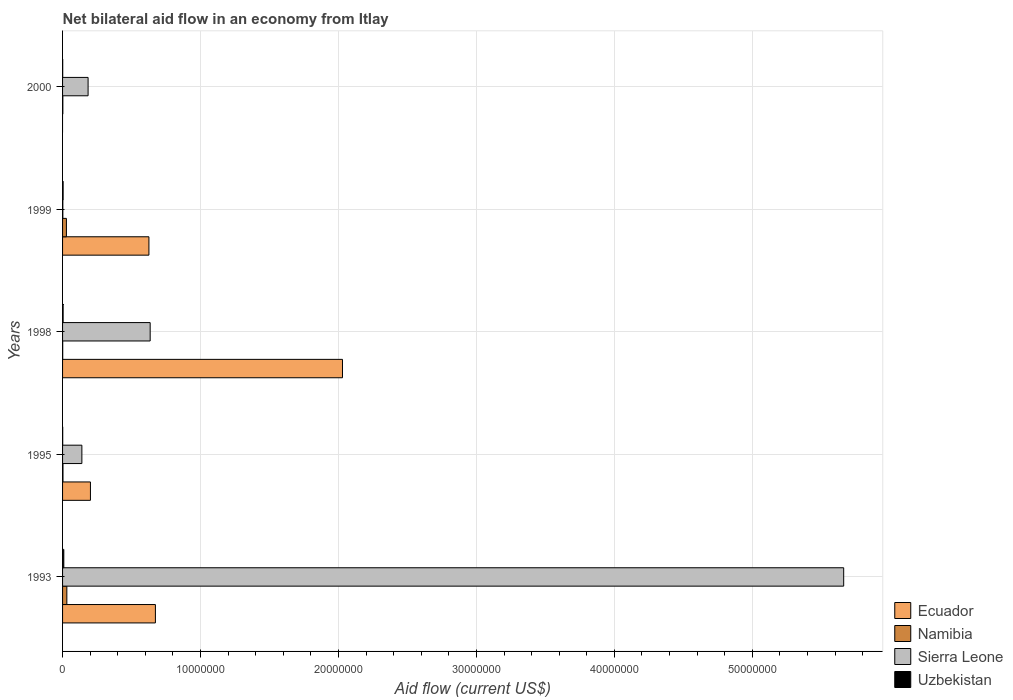How many different coloured bars are there?
Offer a terse response. 4. Are the number of bars per tick equal to the number of legend labels?
Your response must be concise. No. Are the number of bars on each tick of the Y-axis equal?
Provide a short and direct response. No. How many bars are there on the 3rd tick from the bottom?
Keep it short and to the point. 4. What is the label of the 5th group of bars from the top?
Provide a succinct answer. 1993. In how many cases, is the number of bars for a given year not equal to the number of legend labels?
Offer a very short reply. 1. What is the net bilateral aid flow in Uzbekistan in 1993?
Make the answer very short. 9.00e+04. Across all years, what is the maximum net bilateral aid flow in Ecuador?
Ensure brevity in your answer.  2.03e+07. Across all years, what is the minimum net bilateral aid flow in Ecuador?
Keep it short and to the point. 0. In which year was the net bilateral aid flow in Sierra Leone maximum?
Your answer should be compact. 1993. What is the difference between the net bilateral aid flow in Sierra Leone in 1993 and that in 2000?
Make the answer very short. 5.48e+07. What is the difference between the net bilateral aid flow in Namibia in 1993 and the net bilateral aid flow in Sierra Leone in 1995?
Ensure brevity in your answer.  -1.09e+06. In the year 2000, what is the difference between the net bilateral aid flow in Uzbekistan and net bilateral aid flow in Sierra Leone?
Provide a short and direct response. -1.84e+06. What is the ratio of the net bilateral aid flow in Uzbekistan in 1998 to that in 2000?
Your answer should be compact. 4. What is the difference between the highest and the second highest net bilateral aid flow in Sierra Leone?
Your answer should be very brief. 5.03e+07. What is the difference between the highest and the lowest net bilateral aid flow in Sierra Leone?
Offer a very short reply. 5.66e+07. Is the sum of the net bilateral aid flow in Ecuador in 1998 and 1999 greater than the maximum net bilateral aid flow in Uzbekistan across all years?
Provide a succinct answer. Yes. Is it the case that in every year, the sum of the net bilateral aid flow in Uzbekistan and net bilateral aid flow in Sierra Leone is greater than the sum of net bilateral aid flow in Ecuador and net bilateral aid flow in Namibia?
Your answer should be compact. No. Are the values on the major ticks of X-axis written in scientific E-notation?
Your answer should be compact. No. Does the graph contain any zero values?
Your response must be concise. Yes. Does the graph contain grids?
Provide a succinct answer. Yes. Where does the legend appear in the graph?
Make the answer very short. Bottom right. How many legend labels are there?
Give a very brief answer. 4. How are the legend labels stacked?
Keep it short and to the point. Vertical. What is the title of the graph?
Give a very brief answer. Net bilateral aid flow in an economy from Itlay. Does "Belize" appear as one of the legend labels in the graph?
Make the answer very short. No. What is the label or title of the X-axis?
Provide a succinct answer. Aid flow (current US$). What is the Aid flow (current US$) in Ecuador in 1993?
Offer a very short reply. 6.73e+06. What is the Aid flow (current US$) of Namibia in 1993?
Give a very brief answer. 3.10e+05. What is the Aid flow (current US$) in Sierra Leone in 1993?
Ensure brevity in your answer.  5.66e+07. What is the Aid flow (current US$) of Uzbekistan in 1993?
Your answer should be very brief. 9.00e+04. What is the Aid flow (current US$) in Ecuador in 1995?
Provide a short and direct response. 2.02e+06. What is the Aid flow (current US$) of Sierra Leone in 1995?
Keep it short and to the point. 1.40e+06. What is the Aid flow (current US$) of Ecuador in 1998?
Your response must be concise. 2.03e+07. What is the Aid flow (current US$) in Sierra Leone in 1998?
Make the answer very short. 6.35e+06. What is the Aid flow (current US$) of Uzbekistan in 1998?
Your answer should be compact. 4.00e+04. What is the Aid flow (current US$) in Ecuador in 1999?
Make the answer very short. 6.26e+06. What is the Aid flow (current US$) in Namibia in 1999?
Your response must be concise. 2.80e+05. What is the Aid flow (current US$) in Uzbekistan in 1999?
Provide a succinct answer. 4.00e+04. What is the Aid flow (current US$) in Ecuador in 2000?
Keep it short and to the point. 0. What is the Aid flow (current US$) of Sierra Leone in 2000?
Your answer should be compact. 1.85e+06. What is the Aid flow (current US$) of Uzbekistan in 2000?
Give a very brief answer. 10000. Across all years, what is the maximum Aid flow (current US$) in Ecuador?
Provide a short and direct response. 2.03e+07. Across all years, what is the maximum Aid flow (current US$) of Namibia?
Keep it short and to the point. 3.10e+05. Across all years, what is the maximum Aid flow (current US$) of Sierra Leone?
Your answer should be compact. 5.66e+07. Across all years, what is the minimum Aid flow (current US$) in Ecuador?
Provide a short and direct response. 0. Across all years, what is the minimum Aid flow (current US$) in Sierra Leone?
Offer a very short reply. 2.00e+04. Across all years, what is the minimum Aid flow (current US$) of Uzbekistan?
Your response must be concise. 10000. What is the total Aid flow (current US$) of Ecuador in the graph?
Give a very brief answer. 3.53e+07. What is the total Aid flow (current US$) in Namibia in the graph?
Offer a very short reply. 6.50e+05. What is the total Aid flow (current US$) of Sierra Leone in the graph?
Ensure brevity in your answer.  6.62e+07. What is the difference between the Aid flow (current US$) of Ecuador in 1993 and that in 1995?
Offer a terse response. 4.71e+06. What is the difference between the Aid flow (current US$) of Namibia in 1993 and that in 1995?
Make the answer very short. 2.80e+05. What is the difference between the Aid flow (current US$) of Sierra Leone in 1993 and that in 1995?
Your answer should be very brief. 5.52e+07. What is the difference between the Aid flow (current US$) in Uzbekistan in 1993 and that in 1995?
Ensure brevity in your answer.  8.00e+04. What is the difference between the Aid flow (current US$) in Ecuador in 1993 and that in 1998?
Your answer should be very brief. -1.36e+07. What is the difference between the Aid flow (current US$) in Sierra Leone in 1993 and that in 1998?
Make the answer very short. 5.03e+07. What is the difference between the Aid flow (current US$) in Uzbekistan in 1993 and that in 1998?
Make the answer very short. 5.00e+04. What is the difference between the Aid flow (current US$) of Sierra Leone in 1993 and that in 1999?
Give a very brief answer. 5.66e+07. What is the difference between the Aid flow (current US$) in Sierra Leone in 1993 and that in 2000?
Give a very brief answer. 5.48e+07. What is the difference between the Aid flow (current US$) in Ecuador in 1995 and that in 1998?
Make the answer very short. -1.83e+07. What is the difference between the Aid flow (current US$) in Namibia in 1995 and that in 1998?
Your answer should be compact. 2.00e+04. What is the difference between the Aid flow (current US$) of Sierra Leone in 1995 and that in 1998?
Provide a short and direct response. -4.95e+06. What is the difference between the Aid flow (current US$) of Uzbekistan in 1995 and that in 1998?
Provide a succinct answer. -3.00e+04. What is the difference between the Aid flow (current US$) in Ecuador in 1995 and that in 1999?
Offer a very short reply. -4.24e+06. What is the difference between the Aid flow (current US$) of Sierra Leone in 1995 and that in 1999?
Keep it short and to the point. 1.38e+06. What is the difference between the Aid flow (current US$) of Uzbekistan in 1995 and that in 1999?
Your answer should be compact. -3.00e+04. What is the difference between the Aid flow (current US$) in Namibia in 1995 and that in 2000?
Your answer should be compact. 10000. What is the difference between the Aid flow (current US$) in Sierra Leone in 1995 and that in 2000?
Provide a succinct answer. -4.50e+05. What is the difference between the Aid flow (current US$) of Ecuador in 1998 and that in 1999?
Ensure brevity in your answer.  1.40e+07. What is the difference between the Aid flow (current US$) of Sierra Leone in 1998 and that in 1999?
Ensure brevity in your answer.  6.33e+06. What is the difference between the Aid flow (current US$) in Uzbekistan in 1998 and that in 1999?
Your answer should be compact. 0. What is the difference between the Aid flow (current US$) of Namibia in 1998 and that in 2000?
Your answer should be compact. -10000. What is the difference between the Aid flow (current US$) in Sierra Leone in 1998 and that in 2000?
Your answer should be very brief. 4.50e+06. What is the difference between the Aid flow (current US$) in Sierra Leone in 1999 and that in 2000?
Your answer should be very brief. -1.83e+06. What is the difference between the Aid flow (current US$) of Uzbekistan in 1999 and that in 2000?
Give a very brief answer. 3.00e+04. What is the difference between the Aid flow (current US$) of Ecuador in 1993 and the Aid flow (current US$) of Namibia in 1995?
Keep it short and to the point. 6.70e+06. What is the difference between the Aid flow (current US$) in Ecuador in 1993 and the Aid flow (current US$) in Sierra Leone in 1995?
Your answer should be very brief. 5.33e+06. What is the difference between the Aid flow (current US$) of Ecuador in 1993 and the Aid flow (current US$) of Uzbekistan in 1995?
Keep it short and to the point. 6.72e+06. What is the difference between the Aid flow (current US$) of Namibia in 1993 and the Aid flow (current US$) of Sierra Leone in 1995?
Provide a short and direct response. -1.09e+06. What is the difference between the Aid flow (current US$) in Namibia in 1993 and the Aid flow (current US$) in Uzbekistan in 1995?
Your response must be concise. 3.00e+05. What is the difference between the Aid flow (current US$) of Sierra Leone in 1993 and the Aid flow (current US$) of Uzbekistan in 1995?
Keep it short and to the point. 5.66e+07. What is the difference between the Aid flow (current US$) of Ecuador in 1993 and the Aid flow (current US$) of Namibia in 1998?
Ensure brevity in your answer.  6.72e+06. What is the difference between the Aid flow (current US$) in Ecuador in 1993 and the Aid flow (current US$) in Sierra Leone in 1998?
Offer a terse response. 3.80e+05. What is the difference between the Aid flow (current US$) in Ecuador in 1993 and the Aid flow (current US$) in Uzbekistan in 1998?
Ensure brevity in your answer.  6.69e+06. What is the difference between the Aid flow (current US$) in Namibia in 1993 and the Aid flow (current US$) in Sierra Leone in 1998?
Your response must be concise. -6.04e+06. What is the difference between the Aid flow (current US$) in Namibia in 1993 and the Aid flow (current US$) in Uzbekistan in 1998?
Ensure brevity in your answer.  2.70e+05. What is the difference between the Aid flow (current US$) of Sierra Leone in 1993 and the Aid flow (current US$) of Uzbekistan in 1998?
Keep it short and to the point. 5.66e+07. What is the difference between the Aid flow (current US$) of Ecuador in 1993 and the Aid flow (current US$) of Namibia in 1999?
Ensure brevity in your answer.  6.45e+06. What is the difference between the Aid flow (current US$) of Ecuador in 1993 and the Aid flow (current US$) of Sierra Leone in 1999?
Your answer should be compact. 6.71e+06. What is the difference between the Aid flow (current US$) in Ecuador in 1993 and the Aid flow (current US$) in Uzbekistan in 1999?
Give a very brief answer. 6.69e+06. What is the difference between the Aid flow (current US$) of Namibia in 1993 and the Aid flow (current US$) of Sierra Leone in 1999?
Make the answer very short. 2.90e+05. What is the difference between the Aid flow (current US$) in Sierra Leone in 1993 and the Aid flow (current US$) in Uzbekistan in 1999?
Keep it short and to the point. 5.66e+07. What is the difference between the Aid flow (current US$) in Ecuador in 1993 and the Aid flow (current US$) in Namibia in 2000?
Provide a short and direct response. 6.71e+06. What is the difference between the Aid flow (current US$) in Ecuador in 1993 and the Aid flow (current US$) in Sierra Leone in 2000?
Provide a short and direct response. 4.88e+06. What is the difference between the Aid flow (current US$) of Ecuador in 1993 and the Aid flow (current US$) of Uzbekistan in 2000?
Make the answer very short. 6.72e+06. What is the difference between the Aid flow (current US$) in Namibia in 1993 and the Aid flow (current US$) in Sierra Leone in 2000?
Offer a very short reply. -1.54e+06. What is the difference between the Aid flow (current US$) of Namibia in 1993 and the Aid flow (current US$) of Uzbekistan in 2000?
Your response must be concise. 3.00e+05. What is the difference between the Aid flow (current US$) of Sierra Leone in 1993 and the Aid flow (current US$) of Uzbekistan in 2000?
Provide a short and direct response. 5.66e+07. What is the difference between the Aid flow (current US$) in Ecuador in 1995 and the Aid flow (current US$) in Namibia in 1998?
Provide a succinct answer. 2.01e+06. What is the difference between the Aid flow (current US$) of Ecuador in 1995 and the Aid flow (current US$) of Sierra Leone in 1998?
Give a very brief answer. -4.33e+06. What is the difference between the Aid flow (current US$) of Ecuador in 1995 and the Aid flow (current US$) of Uzbekistan in 1998?
Make the answer very short. 1.98e+06. What is the difference between the Aid flow (current US$) of Namibia in 1995 and the Aid flow (current US$) of Sierra Leone in 1998?
Ensure brevity in your answer.  -6.32e+06. What is the difference between the Aid flow (current US$) in Namibia in 1995 and the Aid flow (current US$) in Uzbekistan in 1998?
Offer a terse response. -10000. What is the difference between the Aid flow (current US$) in Sierra Leone in 1995 and the Aid flow (current US$) in Uzbekistan in 1998?
Ensure brevity in your answer.  1.36e+06. What is the difference between the Aid flow (current US$) of Ecuador in 1995 and the Aid flow (current US$) of Namibia in 1999?
Your answer should be very brief. 1.74e+06. What is the difference between the Aid flow (current US$) of Ecuador in 1995 and the Aid flow (current US$) of Sierra Leone in 1999?
Make the answer very short. 2.00e+06. What is the difference between the Aid flow (current US$) in Ecuador in 1995 and the Aid flow (current US$) in Uzbekistan in 1999?
Your response must be concise. 1.98e+06. What is the difference between the Aid flow (current US$) of Namibia in 1995 and the Aid flow (current US$) of Sierra Leone in 1999?
Ensure brevity in your answer.  10000. What is the difference between the Aid flow (current US$) in Namibia in 1995 and the Aid flow (current US$) in Uzbekistan in 1999?
Offer a very short reply. -10000. What is the difference between the Aid flow (current US$) of Sierra Leone in 1995 and the Aid flow (current US$) of Uzbekistan in 1999?
Keep it short and to the point. 1.36e+06. What is the difference between the Aid flow (current US$) in Ecuador in 1995 and the Aid flow (current US$) in Uzbekistan in 2000?
Provide a short and direct response. 2.01e+06. What is the difference between the Aid flow (current US$) in Namibia in 1995 and the Aid flow (current US$) in Sierra Leone in 2000?
Ensure brevity in your answer.  -1.82e+06. What is the difference between the Aid flow (current US$) of Namibia in 1995 and the Aid flow (current US$) of Uzbekistan in 2000?
Give a very brief answer. 2.00e+04. What is the difference between the Aid flow (current US$) in Sierra Leone in 1995 and the Aid flow (current US$) in Uzbekistan in 2000?
Your response must be concise. 1.39e+06. What is the difference between the Aid flow (current US$) of Ecuador in 1998 and the Aid flow (current US$) of Namibia in 1999?
Offer a very short reply. 2.00e+07. What is the difference between the Aid flow (current US$) of Ecuador in 1998 and the Aid flow (current US$) of Sierra Leone in 1999?
Make the answer very short. 2.03e+07. What is the difference between the Aid flow (current US$) in Ecuador in 1998 and the Aid flow (current US$) in Uzbekistan in 1999?
Keep it short and to the point. 2.02e+07. What is the difference between the Aid flow (current US$) in Sierra Leone in 1998 and the Aid flow (current US$) in Uzbekistan in 1999?
Keep it short and to the point. 6.31e+06. What is the difference between the Aid flow (current US$) of Ecuador in 1998 and the Aid flow (current US$) of Namibia in 2000?
Ensure brevity in your answer.  2.03e+07. What is the difference between the Aid flow (current US$) of Ecuador in 1998 and the Aid flow (current US$) of Sierra Leone in 2000?
Give a very brief answer. 1.84e+07. What is the difference between the Aid flow (current US$) of Ecuador in 1998 and the Aid flow (current US$) of Uzbekistan in 2000?
Your answer should be very brief. 2.03e+07. What is the difference between the Aid flow (current US$) in Namibia in 1998 and the Aid flow (current US$) in Sierra Leone in 2000?
Ensure brevity in your answer.  -1.84e+06. What is the difference between the Aid flow (current US$) in Sierra Leone in 1998 and the Aid flow (current US$) in Uzbekistan in 2000?
Give a very brief answer. 6.34e+06. What is the difference between the Aid flow (current US$) in Ecuador in 1999 and the Aid flow (current US$) in Namibia in 2000?
Your response must be concise. 6.24e+06. What is the difference between the Aid flow (current US$) of Ecuador in 1999 and the Aid flow (current US$) of Sierra Leone in 2000?
Give a very brief answer. 4.41e+06. What is the difference between the Aid flow (current US$) of Ecuador in 1999 and the Aid flow (current US$) of Uzbekistan in 2000?
Provide a short and direct response. 6.25e+06. What is the difference between the Aid flow (current US$) in Namibia in 1999 and the Aid flow (current US$) in Sierra Leone in 2000?
Make the answer very short. -1.57e+06. What is the difference between the Aid flow (current US$) of Namibia in 1999 and the Aid flow (current US$) of Uzbekistan in 2000?
Keep it short and to the point. 2.70e+05. What is the difference between the Aid flow (current US$) in Sierra Leone in 1999 and the Aid flow (current US$) in Uzbekistan in 2000?
Your answer should be compact. 10000. What is the average Aid flow (current US$) in Ecuador per year?
Make the answer very short. 7.06e+06. What is the average Aid flow (current US$) of Namibia per year?
Ensure brevity in your answer.  1.30e+05. What is the average Aid flow (current US$) of Sierra Leone per year?
Your answer should be very brief. 1.32e+07. What is the average Aid flow (current US$) in Uzbekistan per year?
Provide a short and direct response. 3.80e+04. In the year 1993, what is the difference between the Aid flow (current US$) of Ecuador and Aid flow (current US$) of Namibia?
Offer a very short reply. 6.42e+06. In the year 1993, what is the difference between the Aid flow (current US$) in Ecuador and Aid flow (current US$) in Sierra Leone?
Your answer should be very brief. -4.99e+07. In the year 1993, what is the difference between the Aid flow (current US$) in Ecuador and Aid flow (current US$) in Uzbekistan?
Provide a succinct answer. 6.64e+06. In the year 1993, what is the difference between the Aid flow (current US$) in Namibia and Aid flow (current US$) in Sierra Leone?
Provide a succinct answer. -5.63e+07. In the year 1993, what is the difference between the Aid flow (current US$) in Sierra Leone and Aid flow (current US$) in Uzbekistan?
Your response must be concise. 5.65e+07. In the year 1995, what is the difference between the Aid flow (current US$) of Ecuador and Aid flow (current US$) of Namibia?
Offer a very short reply. 1.99e+06. In the year 1995, what is the difference between the Aid flow (current US$) in Ecuador and Aid flow (current US$) in Sierra Leone?
Offer a very short reply. 6.20e+05. In the year 1995, what is the difference between the Aid flow (current US$) in Ecuador and Aid flow (current US$) in Uzbekistan?
Offer a terse response. 2.01e+06. In the year 1995, what is the difference between the Aid flow (current US$) of Namibia and Aid flow (current US$) of Sierra Leone?
Your answer should be compact. -1.37e+06. In the year 1995, what is the difference between the Aid flow (current US$) of Namibia and Aid flow (current US$) of Uzbekistan?
Make the answer very short. 2.00e+04. In the year 1995, what is the difference between the Aid flow (current US$) of Sierra Leone and Aid flow (current US$) of Uzbekistan?
Keep it short and to the point. 1.39e+06. In the year 1998, what is the difference between the Aid flow (current US$) of Ecuador and Aid flow (current US$) of Namibia?
Your response must be concise. 2.03e+07. In the year 1998, what is the difference between the Aid flow (current US$) of Ecuador and Aid flow (current US$) of Sierra Leone?
Your answer should be very brief. 1.39e+07. In the year 1998, what is the difference between the Aid flow (current US$) of Ecuador and Aid flow (current US$) of Uzbekistan?
Make the answer very short. 2.02e+07. In the year 1998, what is the difference between the Aid flow (current US$) in Namibia and Aid flow (current US$) in Sierra Leone?
Give a very brief answer. -6.34e+06. In the year 1998, what is the difference between the Aid flow (current US$) in Namibia and Aid flow (current US$) in Uzbekistan?
Make the answer very short. -3.00e+04. In the year 1998, what is the difference between the Aid flow (current US$) of Sierra Leone and Aid flow (current US$) of Uzbekistan?
Provide a succinct answer. 6.31e+06. In the year 1999, what is the difference between the Aid flow (current US$) of Ecuador and Aid flow (current US$) of Namibia?
Give a very brief answer. 5.98e+06. In the year 1999, what is the difference between the Aid flow (current US$) of Ecuador and Aid flow (current US$) of Sierra Leone?
Give a very brief answer. 6.24e+06. In the year 1999, what is the difference between the Aid flow (current US$) of Ecuador and Aid flow (current US$) of Uzbekistan?
Give a very brief answer. 6.22e+06. In the year 2000, what is the difference between the Aid flow (current US$) of Namibia and Aid flow (current US$) of Sierra Leone?
Offer a terse response. -1.83e+06. In the year 2000, what is the difference between the Aid flow (current US$) in Sierra Leone and Aid flow (current US$) in Uzbekistan?
Give a very brief answer. 1.84e+06. What is the ratio of the Aid flow (current US$) in Ecuador in 1993 to that in 1995?
Keep it short and to the point. 3.33. What is the ratio of the Aid flow (current US$) in Namibia in 1993 to that in 1995?
Your answer should be compact. 10.33. What is the ratio of the Aid flow (current US$) of Sierra Leone in 1993 to that in 1995?
Make the answer very short. 40.44. What is the ratio of the Aid flow (current US$) in Uzbekistan in 1993 to that in 1995?
Provide a short and direct response. 9. What is the ratio of the Aid flow (current US$) in Ecuador in 1993 to that in 1998?
Your answer should be very brief. 0.33. What is the ratio of the Aid flow (current US$) of Sierra Leone in 1993 to that in 1998?
Your response must be concise. 8.92. What is the ratio of the Aid flow (current US$) of Uzbekistan in 1993 to that in 1998?
Ensure brevity in your answer.  2.25. What is the ratio of the Aid flow (current US$) of Ecuador in 1993 to that in 1999?
Keep it short and to the point. 1.08. What is the ratio of the Aid flow (current US$) of Namibia in 1993 to that in 1999?
Offer a very short reply. 1.11. What is the ratio of the Aid flow (current US$) of Sierra Leone in 1993 to that in 1999?
Offer a terse response. 2831. What is the ratio of the Aid flow (current US$) in Uzbekistan in 1993 to that in 1999?
Your answer should be very brief. 2.25. What is the ratio of the Aid flow (current US$) in Namibia in 1993 to that in 2000?
Keep it short and to the point. 15.5. What is the ratio of the Aid flow (current US$) in Sierra Leone in 1993 to that in 2000?
Your response must be concise. 30.61. What is the ratio of the Aid flow (current US$) of Uzbekistan in 1993 to that in 2000?
Keep it short and to the point. 9. What is the ratio of the Aid flow (current US$) of Ecuador in 1995 to that in 1998?
Offer a terse response. 0.1. What is the ratio of the Aid flow (current US$) in Namibia in 1995 to that in 1998?
Your answer should be very brief. 3. What is the ratio of the Aid flow (current US$) of Sierra Leone in 1995 to that in 1998?
Provide a succinct answer. 0.22. What is the ratio of the Aid flow (current US$) in Uzbekistan in 1995 to that in 1998?
Ensure brevity in your answer.  0.25. What is the ratio of the Aid flow (current US$) of Ecuador in 1995 to that in 1999?
Keep it short and to the point. 0.32. What is the ratio of the Aid flow (current US$) in Namibia in 1995 to that in 1999?
Your answer should be compact. 0.11. What is the ratio of the Aid flow (current US$) of Sierra Leone in 1995 to that in 1999?
Give a very brief answer. 70. What is the ratio of the Aid flow (current US$) of Namibia in 1995 to that in 2000?
Ensure brevity in your answer.  1.5. What is the ratio of the Aid flow (current US$) in Sierra Leone in 1995 to that in 2000?
Your answer should be compact. 0.76. What is the ratio of the Aid flow (current US$) in Uzbekistan in 1995 to that in 2000?
Offer a terse response. 1. What is the ratio of the Aid flow (current US$) in Ecuador in 1998 to that in 1999?
Your response must be concise. 3.24. What is the ratio of the Aid flow (current US$) in Namibia in 1998 to that in 1999?
Provide a succinct answer. 0.04. What is the ratio of the Aid flow (current US$) of Sierra Leone in 1998 to that in 1999?
Provide a succinct answer. 317.5. What is the ratio of the Aid flow (current US$) of Sierra Leone in 1998 to that in 2000?
Your answer should be compact. 3.43. What is the ratio of the Aid flow (current US$) in Uzbekistan in 1998 to that in 2000?
Offer a terse response. 4. What is the ratio of the Aid flow (current US$) in Sierra Leone in 1999 to that in 2000?
Offer a terse response. 0.01. What is the difference between the highest and the second highest Aid flow (current US$) in Ecuador?
Your response must be concise. 1.36e+07. What is the difference between the highest and the second highest Aid flow (current US$) in Namibia?
Provide a short and direct response. 3.00e+04. What is the difference between the highest and the second highest Aid flow (current US$) of Sierra Leone?
Ensure brevity in your answer.  5.03e+07. What is the difference between the highest and the lowest Aid flow (current US$) of Ecuador?
Make the answer very short. 2.03e+07. What is the difference between the highest and the lowest Aid flow (current US$) of Namibia?
Your answer should be compact. 3.00e+05. What is the difference between the highest and the lowest Aid flow (current US$) in Sierra Leone?
Offer a very short reply. 5.66e+07. What is the difference between the highest and the lowest Aid flow (current US$) of Uzbekistan?
Ensure brevity in your answer.  8.00e+04. 